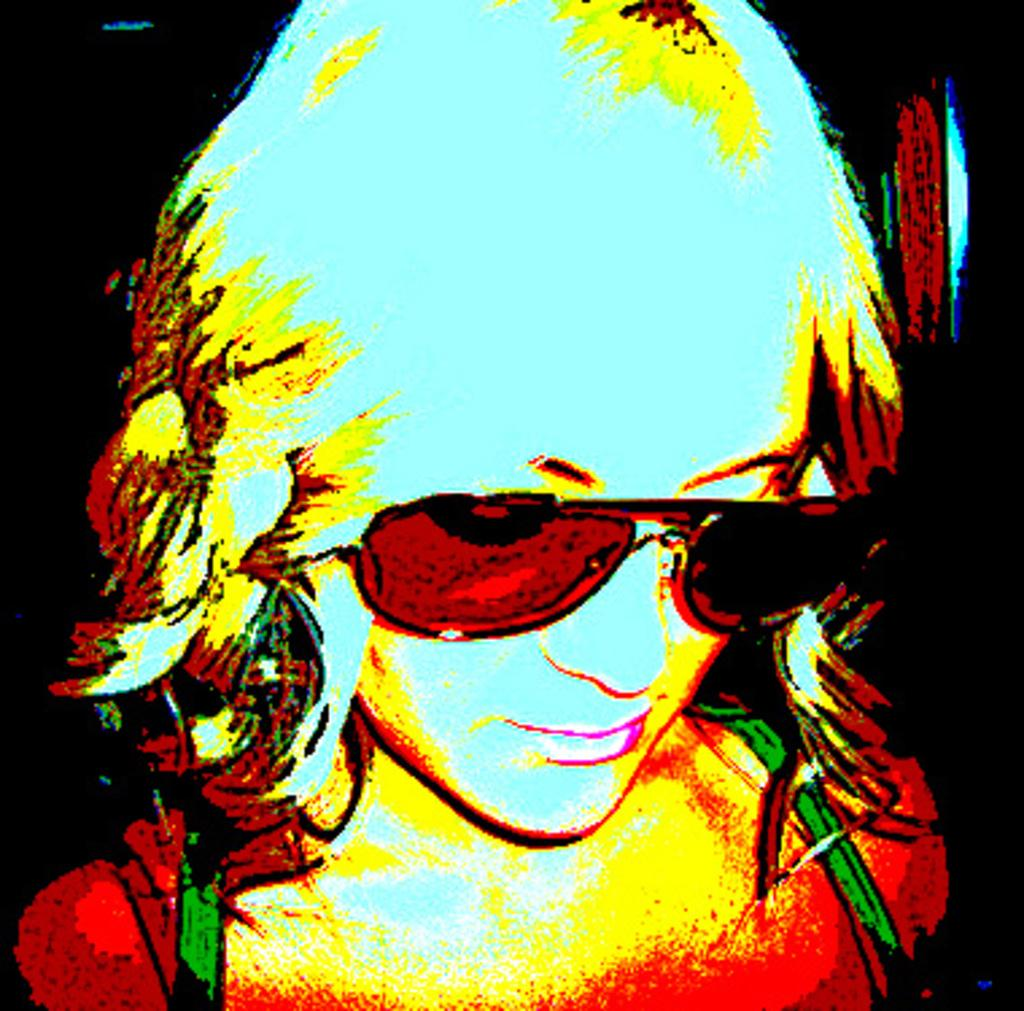What type of image is being described? The image is an edited image. Who or what is the main subject of the image? The subject of the image is a woman. What type of knot is the woman wearing in the image? There is no knot visible in the image, as the focus is on the woman as the main subject. 